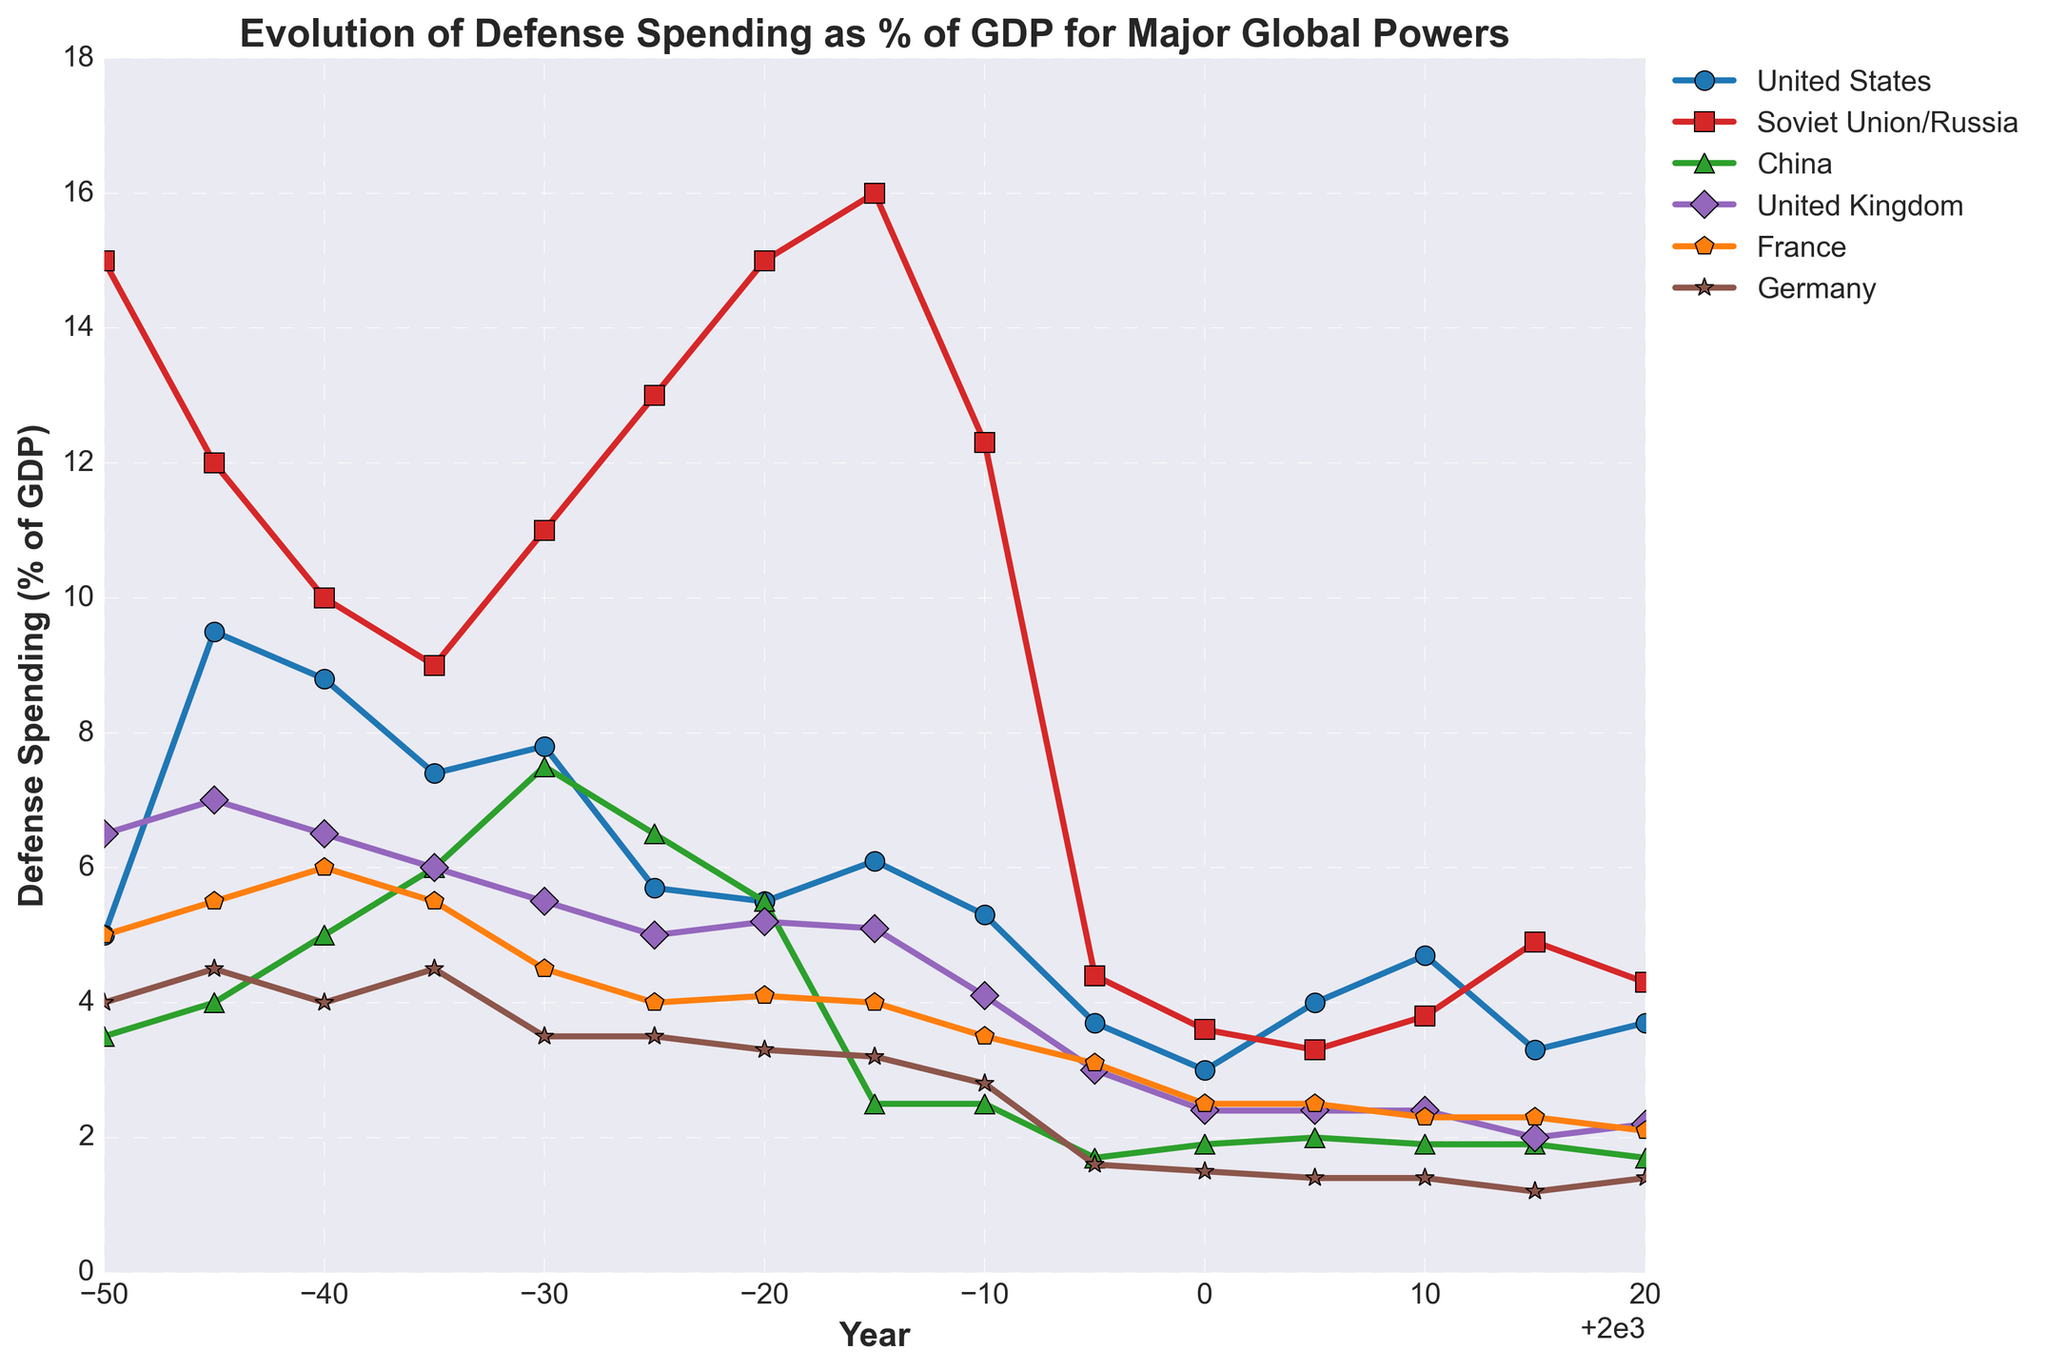Which country had the highest defense spending as a percentage of GDP in 1955? Looking at the figure, the country with the highest defense spending (% of GDP) in 1955 is the Soviet Union/Russia at 12.0%.
Answer: Soviet Union/Russia What was the primary trend in defense spending for the United States from 1950 to 2020? Observing the United States line in the figure, it initially rises to a peak in the mid-1950s, then generally declines with periods of smaller increases and decreases, before stabilizing between 3-4% towards 2020.
Answer: General decline Which two countries' defense spending as a percentage of GDP crossed paths around 1970? Identifying the lines that intersect around 1970, China and Germany's defense spending lines briefly cross around this year.
Answer: China and Germany What is the difference in defense spending percentage between the United Kingdom and Germany in 2020? In 2020, the United Kingdom's defense spending is approximately 2.2%, whereas Germany's is around 1.4%. Subtracting these gives 2.2% - 1.4% = 0.8%.
Answer: 0.8% Which country shows a rising trend in defense spending as a percentage of GDP from 2000 to 2015? Checking the trends between 2000 and 2015, Russia shows a rising trend where its defense spending percentage increases from around 3.6% to 4.9%.
Answer: Russia When did China have the lowest defense spending as a percentage of GDP, and what was the value? Looking at the China's trend line, the lowest value appeared around 1990 and 1995 at approximately 1.7%.
Answer: 1990 and 1995, 1.7% Which country had the most stable defense spending as a percentage of GDP from 1950 to 2020? Examining all countries, Germany exhibits the most stability in its defense spending percentages with values consistently fluctuating but staying within a narrow range between 1.2%-4.5%.
Answer: Germany Compare the defense spending percentages for France in 1960 and 1985. Did it increase or decrease? France's defense spending in 1960 was 6.0%, and in 1985 it was 4.0%. Since 4.0% is less than 6.0%, it shows a decrease.
Answer: Decrease In which decade did the United States experience the steepest decline in its defense spending as a percentage of GDP? Observing the slope trend lines, the steepest decline occurred from the mid-1960s to the mid-1970s.
Answer: 1970s How does the defense spending trend of the Soviet Union/Russia compare to that of France after 1990? Post-1990, the Soviet Union/Russia's defense spending first drops sharply, starts to rise around 2005, whereas France’s spending relatively remains steady with minor fluctuations around 2.0%-3.5%.
Answer: Soviet Union/Russia drops then rises, France steady 